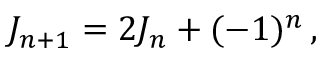Convert formula to latex. <formula><loc_0><loc_0><loc_500><loc_500>J _ { n + 1 } = 2 J _ { n } + ( - 1 ) ^ { n } \, ,</formula> 